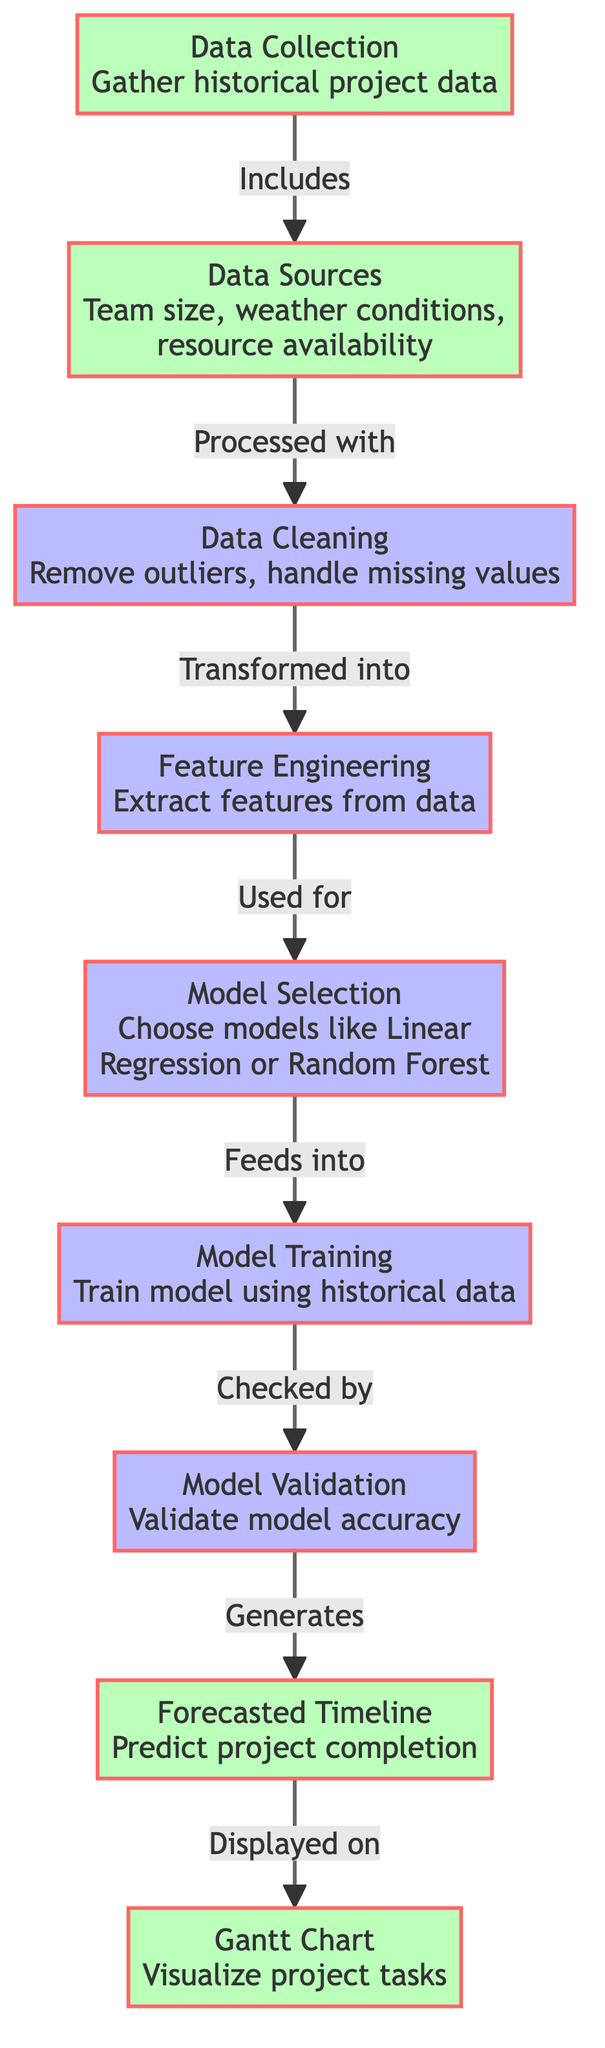What is the first step in the diagram? The diagram starts with the "Data Collection" node, which indicates that collecting historical project data is the initial action in the flow.
Answer: Data Collection How many nodes are in the diagram? By counting all the distinct labeled elements in the diagram, we can determine that there are a total of eight nodes.
Answer: Eight What is the output of the "Model Validation" step? The "Model Validation" step leads to the generation of the "Forecasted Timeline," indicating that the output of validation is the prediction of project completion.
Answer: Forecasted Timeline Which process follows "Feature Engineering"? The diagram indicates that after "Feature Engineering," the next step is "Model Selection," showing the flow of information.
Answer: Model Selection What data source is included in the "Data Collection"? The "Data Sources" node mentions three factors: "Team size," "Weather conditions," and "Resource availability," which are all part of data collection.
Answer: Team size, Weather conditions, Resource availability How is the "Gantt Chart" related to the "Forecasted Timeline"? The diagram shows an arrow from "Forecasted Timeline" to "Gantt Chart," indicating that the predicted completion timeline is displayed on the Gantt chart for visualization.
Answer: Displayed on Which two steps are linked directly? There are multiple links, but specifically, "Model Training" feeds into "Model Validation," indicating a direct relationship between these two processes.
Answer: Model Training, Model Validation What determines the choice of model in the "Model Selection"? The "Model Selection" step takes input from the "Feature Engineering" process, meaning the choice of model is based on the features extracted from the data.
Answer: Feature Engineering What process is concerned with handling outliers? The "Data Cleaning" step is explicitly mentioned to handle tasks such as removing outliers and addressing missing values in the data collected.
Answer: Data Cleaning 